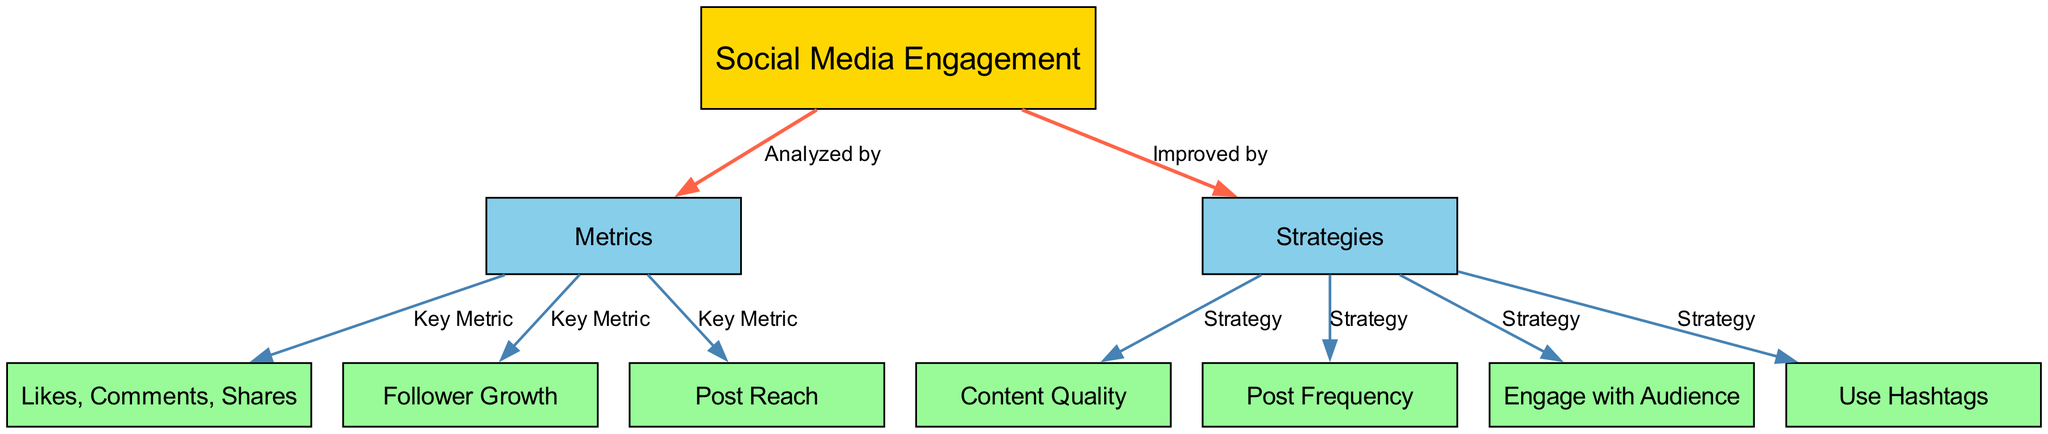What is the main subject of the diagram? The main subject is stated in the root node labeled "Social Media Engagement". This is confirmed by the arrangement of nodes where all other nodes connect back to this primary node.
Answer: Social Media Engagement How many nodes are in the diagram? Counting the "nodes" listed in the data, there are a total of 10 nodes including the main subject, categories, and subcategories.
Answer: 10 Which metrics are considered key metrics in the diagram? The key metrics are directly indicated by the edges that connect the "Metrics" node to three other nodes namely "Likes, Comments, Shares", "Follower Growth", and "Post Reach". This direct connection signifies their importance.
Answer: Likes, Comments, Shares; Follower Growth; Post Reach What strategies are listed in the diagram? The strategies can be found by looking for the connections from the "Strategies" node. There are four strategies indicated: "Content Quality", "Post Frequency", "Engage with Audience", and "Use Hashtags". Each is linked directly to the strategies node.
Answer: Content Quality; Post Frequency; Engage with Audience; Use Hashtags What is the relationship between social media engagement and strategies? The relationship is expressed through the edge labeled "Improved by" which connects the "Social Media Engagement" node to the "Strategies" node. This indicates that various strategies can lead to improvements in social media engagement.
Answer: Improved by Which strategy is aimed at audience interaction? The strategy aimed at audience interaction is indicated by the node "Engage with Audience", which connects directly to the strategies node, portraying its focus on audience interaction.
Answer: Engage with Audience What colors are used for the various types of nodes? The different nodes have specific colors designated: the root node is gold (#FFD700), the main category nodes are sky blue (#87CEEB), and the subcategory nodes are light green (#98FB98). This differentiation in color helps to categorize the information visually.
Answer: Gold; Sky blue; Light green Which node has the most connections? The "Metrics" node connects to three other nodes ("Likes, Comments, Shares", "Follower Growth", "Post Reach"), making it the node with the most connections in the diagram.
Answer: Metrics How are the metrics categorized in the diagram? The metrics are categorized under the single "Metrics" node, and three specific metrics are then depicted as key metrics, indicating a focused type of analysis within the engagement strategies.
Answer: Key Metric 